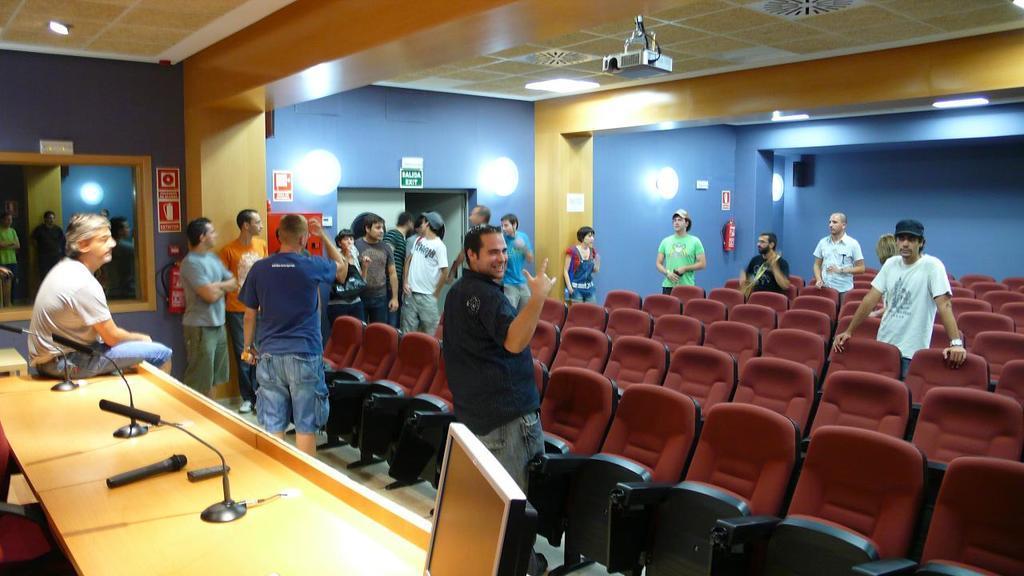Please provide a concise description of this image. At the top we can see ceiling, lights and a projector device. We can see wall, boards, and also lights. We can see empty chairs. All the persons are standing here. We can see a man sitting on a table and on the table we can see mike. 